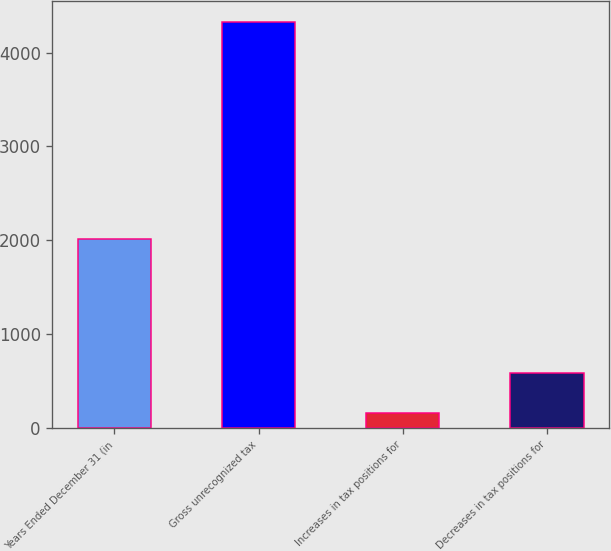Convert chart to OTSL. <chart><loc_0><loc_0><loc_500><loc_500><bar_chart><fcel>Years Ended December 31 (in<fcel>Gross unrecognized tax<fcel>Increases in tax positions for<fcel>Decreases in tax positions for<nl><fcel>2015<fcel>4331<fcel>162<fcel>585.3<nl></chart> 